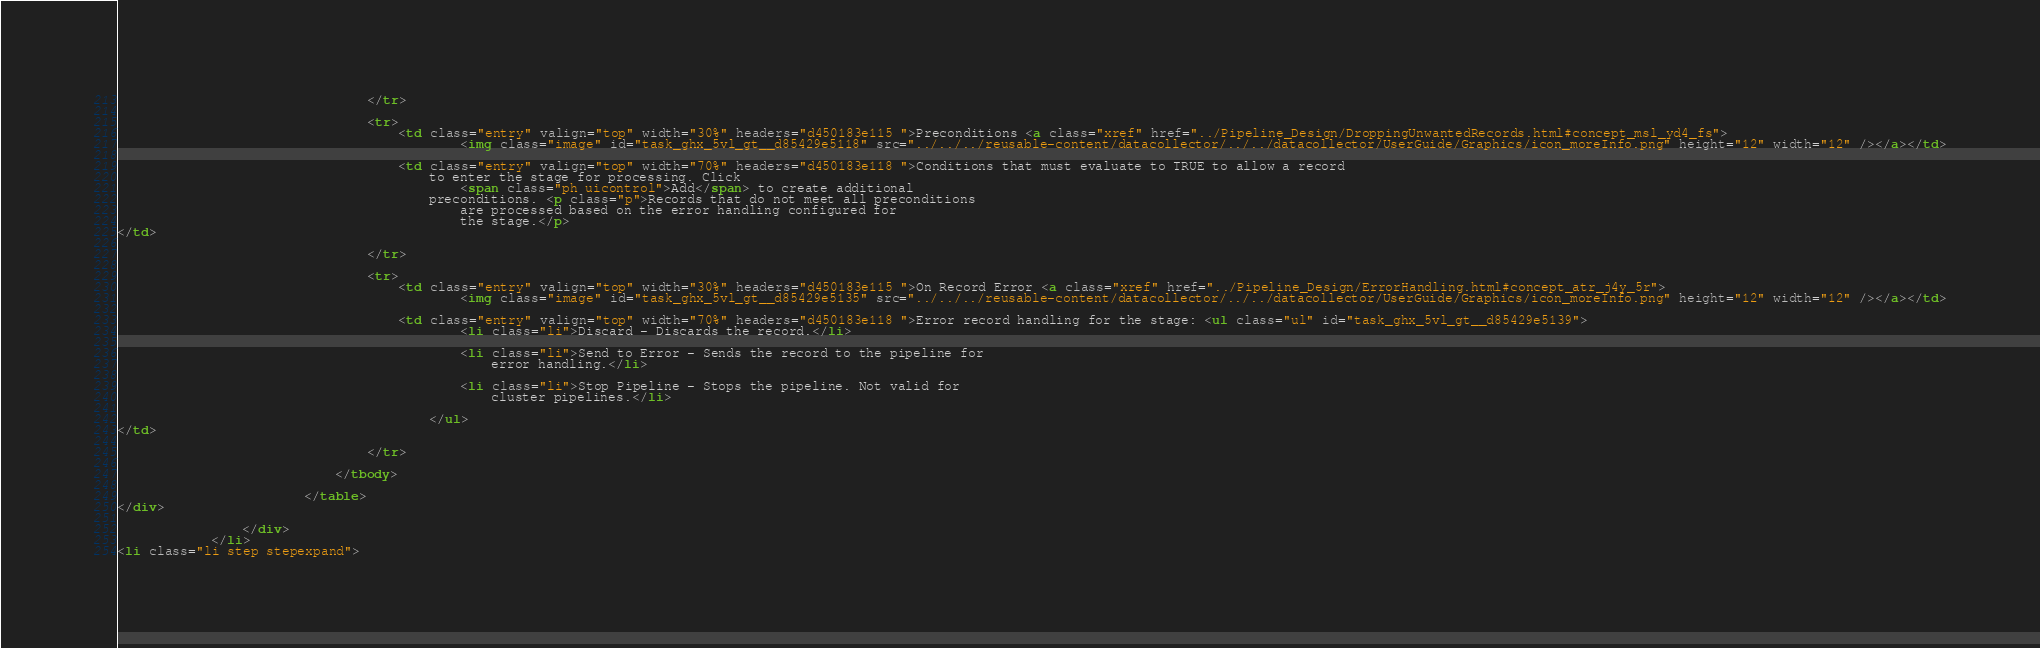Convert code to text. <code><loc_0><loc_0><loc_500><loc_500><_HTML_>                                </tr>

                                <tr>
                                    <td class="entry" valign="top" width="30%" headers="d450183e115 ">Preconditions <a class="xref" href="../Pipeline_Design/DroppingUnwantedRecords.html#concept_msl_yd4_fs">
                                            <img class="image" id="task_ghx_5vl_gt__d85429e5118" src="../../../reusable-content/datacollector/../../datacollector/UserGuide/Graphics/icon_moreInfo.png" height="12" width="12" /></a></td>

                                    <td class="entry" valign="top" width="70%" headers="d450183e118 ">Conditions that must evaluate to TRUE to allow a record
                                        to enter the stage for processing. Click
                                            <span class="ph uicontrol">Add</span> to create additional
                                        preconditions. <p class="p">Records that do not meet all preconditions
                                            are processed based on the error handling configured for
                                            the stage.</p>
</td>

                                </tr>

                                <tr>
                                    <td class="entry" valign="top" width="30%" headers="d450183e115 ">On Record Error <a class="xref" href="../Pipeline_Design/ErrorHandling.html#concept_atr_j4y_5r">
                                            <img class="image" id="task_ghx_5vl_gt__d85429e5135" src="../../../reusable-content/datacollector/../../datacollector/UserGuide/Graphics/icon_moreInfo.png" height="12" width="12" /></a></td>

                                    <td class="entry" valign="top" width="70%" headers="d450183e118 ">Error record handling for the stage: <ul class="ul" id="task_ghx_5vl_gt__d85429e5139">
                                            <li class="li">Discard - Discards the record.</li>

                                            <li class="li">Send to Error - Sends the record to the pipeline for
                                                error handling.</li>

                                            <li class="li">Stop Pipeline - Stops the pipeline. Not valid for
                                                cluster pipelines.</li>

                                        </ul>
</td>

                                </tr>

                            </tbody>

                        </table>
</div>

                </div>
            </li>
<li class="li step stepexpand"></code> 